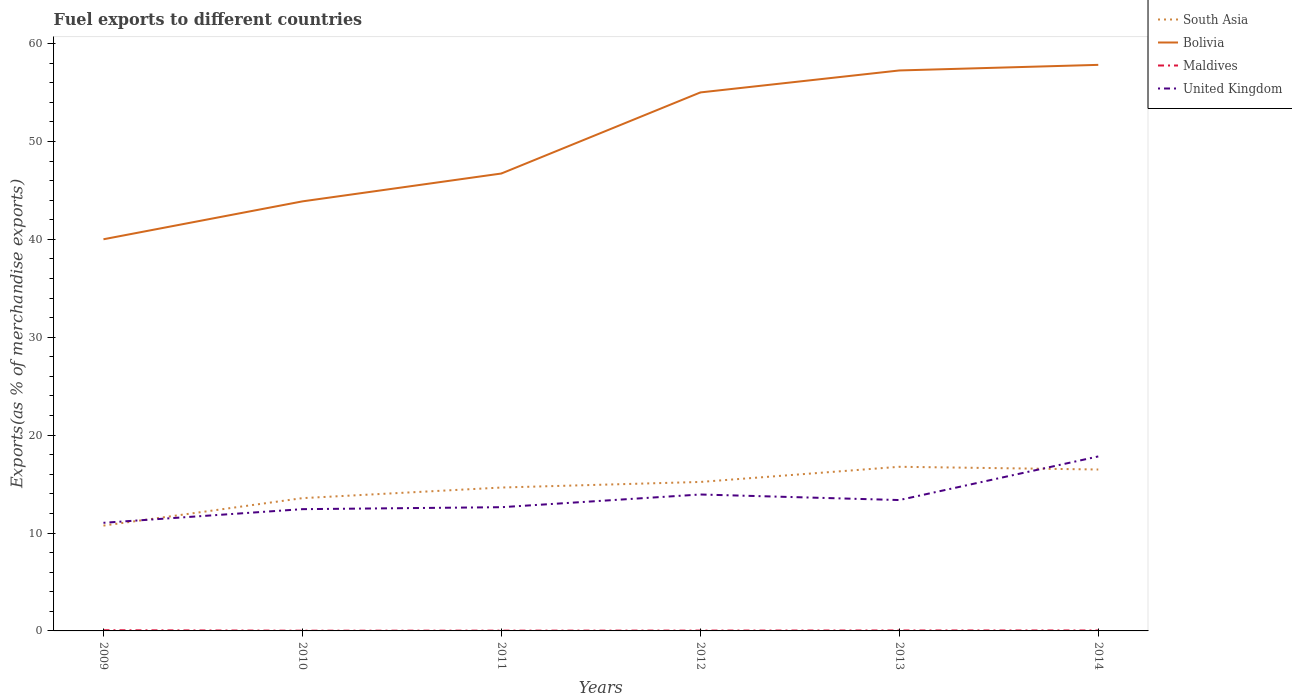How many different coloured lines are there?
Offer a very short reply. 4. Across all years, what is the maximum percentage of exports to different countries in South Asia?
Give a very brief answer. 10.76. In which year was the percentage of exports to different countries in South Asia maximum?
Provide a succinct answer. 2009. What is the total percentage of exports to different countries in United Kingdom in the graph?
Provide a succinct answer. -4.45. What is the difference between the highest and the second highest percentage of exports to different countries in Maldives?
Make the answer very short. 0.05. How many years are there in the graph?
Give a very brief answer. 6. Are the values on the major ticks of Y-axis written in scientific E-notation?
Make the answer very short. No. Does the graph contain any zero values?
Provide a short and direct response. No. Where does the legend appear in the graph?
Offer a terse response. Top right. How many legend labels are there?
Your response must be concise. 4. What is the title of the graph?
Give a very brief answer. Fuel exports to different countries. Does "Canada" appear as one of the legend labels in the graph?
Offer a terse response. No. What is the label or title of the Y-axis?
Make the answer very short. Exports(as % of merchandise exports). What is the Exports(as % of merchandise exports) in South Asia in 2009?
Provide a succinct answer. 10.76. What is the Exports(as % of merchandise exports) of Bolivia in 2009?
Ensure brevity in your answer.  40.01. What is the Exports(as % of merchandise exports) in Maldives in 2009?
Give a very brief answer. 0.07. What is the Exports(as % of merchandise exports) of United Kingdom in 2009?
Your response must be concise. 11.04. What is the Exports(as % of merchandise exports) in South Asia in 2010?
Ensure brevity in your answer.  13.56. What is the Exports(as % of merchandise exports) of Bolivia in 2010?
Your response must be concise. 43.88. What is the Exports(as % of merchandise exports) in Maldives in 2010?
Offer a terse response. 0.02. What is the Exports(as % of merchandise exports) in United Kingdom in 2010?
Give a very brief answer. 12.44. What is the Exports(as % of merchandise exports) of South Asia in 2011?
Your answer should be very brief. 14.65. What is the Exports(as % of merchandise exports) in Bolivia in 2011?
Provide a succinct answer. 46.72. What is the Exports(as % of merchandise exports) of Maldives in 2011?
Offer a terse response. 0.03. What is the Exports(as % of merchandise exports) in United Kingdom in 2011?
Keep it short and to the point. 12.64. What is the Exports(as % of merchandise exports) in South Asia in 2012?
Ensure brevity in your answer.  15.22. What is the Exports(as % of merchandise exports) of Bolivia in 2012?
Your response must be concise. 55.01. What is the Exports(as % of merchandise exports) of Maldives in 2012?
Keep it short and to the point. 0.03. What is the Exports(as % of merchandise exports) in United Kingdom in 2012?
Offer a terse response. 13.94. What is the Exports(as % of merchandise exports) of South Asia in 2013?
Give a very brief answer. 16.77. What is the Exports(as % of merchandise exports) in Bolivia in 2013?
Give a very brief answer. 57.25. What is the Exports(as % of merchandise exports) in Maldives in 2013?
Give a very brief answer. 0.05. What is the Exports(as % of merchandise exports) in United Kingdom in 2013?
Your answer should be compact. 13.37. What is the Exports(as % of merchandise exports) of South Asia in 2014?
Your response must be concise. 16.49. What is the Exports(as % of merchandise exports) in Bolivia in 2014?
Provide a short and direct response. 57.82. What is the Exports(as % of merchandise exports) in Maldives in 2014?
Make the answer very short. 0.05. What is the Exports(as % of merchandise exports) in United Kingdom in 2014?
Provide a short and direct response. 17.82. Across all years, what is the maximum Exports(as % of merchandise exports) in South Asia?
Provide a short and direct response. 16.77. Across all years, what is the maximum Exports(as % of merchandise exports) in Bolivia?
Provide a succinct answer. 57.82. Across all years, what is the maximum Exports(as % of merchandise exports) in Maldives?
Ensure brevity in your answer.  0.07. Across all years, what is the maximum Exports(as % of merchandise exports) of United Kingdom?
Make the answer very short. 17.82. Across all years, what is the minimum Exports(as % of merchandise exports) in South Asia?
Give a very brief answer. 10.76. Across all years, what is the minimum Exports(as % of merchandise exports) in Bolivia?
Your answer should be compact. 40.01. Across all years, what is the minimum Exports(as % of merchandise exports) of Maldives?
Give a very brief answer. 0.02. Across all years, what is the minimum Exports(as % of merchandise exports) of United Kingdom?
Offer a very short reply. 11.04. What is the total Exports(as % of merchandise exports) of South Asia in the graph?
Offer a very short reply. 87.44. What is the total Exports(as % of merchandise exports) of Bolivia in the graph?
Your answer should be very brief. 300.69. What is the total Exports(as % of merchandise exports) in Maldives in the graph?
Make the answer very short. 0.25. What is the total Exports(as % of merchandise exports) in United Kingdom in the graph?
Make the answer very short. 81.25. What is the difference between the Exports(as % of merchandise exports) of South Asia in 2009 and that in 2010?
Your answer should be compact. -2.8. What is the difference between the Exports(as % of merchandise exports) in Bolivia in 2009 and that in 2010?
Provide a short and direct response. -3.87. What is the difference between the Exports(as % of merchandise exports) in Maldives in 2009 and that in 2010?
Ensure brevity in your answer.  0.05. What is the difference between the Exports(as % of merchandise exports) in United Kingdom in 2009 and that in 2010?
Your answer should be very brief. -1.39. What is the difference between the Exports(as % of merchandise exports) in South Asia in 2009 and that in 2011?
Offer a terse response. -3.89. What is the difference between the Exports(as % of merchandise exports) in Bolivia in 2009 and that in 2011?
Make the answer very short. -6.72. What is the difference between the Exports(as % of merchandise exports) of Maldives in 2009 and that in 2011?
Your answer should be very brief. 0.04. What is the difference between the Exports(as % of merchandise exports) of United Kingdom in 2009 and that in 2011?
Your answer should be very brief. -1.59. What is the difference between the Exports(as % of merchandise exports) of South Asia in 2009 and that in 2012?
Make the answer very short. -4.46. What is the difference between the Exports(as % of merchandise exports) of Bolivia in 2009 and that in 2012?
Ensure brevity in your answer.  -15. What is the difference between the Exports(as % of merchandise exports) of Maldives in 2009 and that in 2012?
Ensure brevity in your answer.  0.04. What is the difference between the Exports(as % of merchandise exports) in United Kingdom in 2009 and that in 2012?
Make the answer very short. -2.89. What is the difference between the Exports(as % of merchandise exports) in South Asia in 2009 and that in 2013?
Provide a short and direct response. -6.01. What is the difference between the Exports(as % of merchandise exports) of Bolivia in 2009 and that in 2013?
Provide a succinct answer. -17.24. What is the difference between the Exports(as % of merchandise exports) of Maldives in 2009 and that in 2013?
Provide a succinct answer. 0.03. What is the difference between the Exports(as % of merchandise exports) in United Kingdom in 2009 and that in 2013?
Keep it short and to the point. -2.32. What is the difference between the Exports(as % of merchandise exports) in South Asia in 2009 and that in 2014?
Your answer should be compact. -5.73. What is the difference between the Exports(as % of merchandise exports) of Bolivia in 2009 and that in 2014?
Give a very brief answer. -17.81. What is the difference between the Exports(as % of merchandise exports) in Maldives in 2009 and that in 2014?
Ensure brevity in your answer.  0.03. What is the difference between the Exports(as % of merchandise exports) in United Kingdom in 2009 and that in 2014?
Give a very brief answer. -6.78. What is the difference between the Exports(as % of merchandise exports) of South Asia in 2010 and that in 2011?
Provide a succinct answer. -1.08. What is the difference between the Exports(as % of merchandise exports) in Bolivia in 2010 and that in 2011?
Your answer should be compact. -2.85. What is the difference between the Exports(as % of merchandise exports) of Maldives in 2010 and that in 2011?
Ensure brevity in your answer.  -0.01. What is the difference between the Exports(as % of merchandise exports) of United Kingdom in 2010 and that in 2011?
Ensure brevity in your answer.  -0.2. What is the difference between the Exports(as % of merchandise exports) of South Asia in 2010 and that in 2012?
Make the answer very short. -1.65. What is the difference between the Exports(as % of merchandise exports) in Bolivia in 2010 and that in 2012?
Make the answer very short. -11.13. What is the difference between the Exports(as % of merchandise exports) of Maldives in 2010 and that in 2012?
Your response must be concise. -0.01. What is the difference between the Exports(as % of merchandise exports) of United Kingdom in 2010 and that in 2012?
Offer a very short reply. -1.5. What is the difference between the Exports(as % of merchandise exports) of South Asia in 2010 and that in 2013?
Make the answer very short. -3.2. What is the difference between the Exports(as % of merchandise exports) of Bolivia in 2010 and that in 2013?
Your answer should be compact. -13.37. What is the difference between the Exports(as % of merchandise exports) in Maldives in 2010 and that in 2013?
Offer a terse response. -0.02. What is the difference between the Exports(as % of merchandise exports) in United Kingdom in 2010 and that in 2013?
Make the answer very short. -0.93. What is the difference between the Exports(as % of merchandise exports) of South Asia in 2010 and that in 2014?
Your answer should be very brief. -2.92. What is the difference between the Exports(as % of merchandise exports) in Bolivia in 2010 and that in 2014?
Provide a succinct answer. -13.94. What is the difference between the Exports(as % of merchandise exports) in Maldives in 2010 and that in 2014?
Give a very brief answer. -0.02. What is the difference between the Exports(as % of merchandise exports) in United Kingdom in 2010 and that in 2014?
Your answer should be very brief. -5.38. What is the difference between the Exports(as % of merchandise exports) of South Asia in 2011 and that in 2012?
Ensure brevity in your answer.  -0.57. What is the difference between the Exports(as % of merchandise exports) of Bolivia in 2011 and that in 2012?
Provide a succinct answer. -8.28. What is the difference between the Exports(as % of merchandise exports) in Maldives in 2011 and that in 2012?
Provide a succinct answer. -0.01. What is the difference between the Exports(as % of merchandise exports) of United Kingdom in 2011 and that in 2012?
Provide a short and direct response. -1.3. What is the difference between the Exports(as % of merchandise exports) of South Asia in 2011 and that in 2013?
Offer a terse response. -2.12. What is the difference between the Exports(as % of merchandise exports) in Bolivia in 2011 and that in 2013?
Keep it short and to the point. -10.53. What is the difference between the Exports(as % of merchandise exports) in Maldives in 2011 and that in 2013?
Make the answer very short. -0.02. What is the difference between the Exports(as % of merchandise exports) of United Kingdom in 2011 and that in 2013?
Provide a succinct answer. -0.73. What is the difference between the Exports(as % of merchandise exports) in South Asia in 2011 and that in 2014?
Make the answer very short. -1.84. What is the difference between the Exports(as % of merchandise exports) of Bolivia in 2011 and that in 2014?
Offer a terse response. -11.1. What is the difference between the Exports(as % of merchandise exports) in Maldives in 2011 and that in 2014?
Keep it short and to the point. -0.02. What is the difference between the Exports(as % of merchandise exports) in United Kingdom in 2011 and that in 2014?
Make the answer very short. -5.18. What is the difference between the Exports(as % of merchandise exports) in South Asia in 2012 and that in 2013?
Provide a succinct answer. -1.55. What is the difference between the Exports(as % of merchandise exports) of Bolivia in 2012 and that in 2013?
Your answer should be compact. -2.25. What is the difference between the Exports(as % of merchandise exports) in Maldives in 2012 and that in 2013?
Ensure brevity in your answer.  -0.01. What is the difference between the Exports(as % of merchandise exports) of United Kingdom in 2012 and that in 2013?
Offer a very short reply. 0.57. What is the difference between the Exports(as % of merchandise exports) in South Asia in 2012 and that in 2014?
Your answer should be compact. -1.27. What is the difference between the Exports(as % of merchandise exports) of Bolivia in 2012 and that in 2014?
Your answer should be compact. -2.82. What is the difference between the Exports(as % of merchandise exports) in Maldives in 2012 and that in 2014?
Your answer should be very brief. -0.01. What is the difference between the Exports(as % of merchandise exports) of United Kingdom in 2012 and that in 2014?
Ensure brevity in your answer.  -3.89. What is the difference between the Exports(as % of merchandise exports) in South Asia in 2013 and that in 2014?
Provide a short and direct response. 0.28. What is the difference between the Exports(as % of merchandise exports) of Bolivia in 2013 and that in 2014?
Your answer should be very brief. -0.57. What is the difference between the Exports(as % of merchandise exports) in Maldives in 2013 and that in 2014?
Provide a short and direct response. -0. What is the difference between the Exports(as % of merchandise exports) in United Kingdom in 2013 and that in 2014?
Provide a succinct answer. -4.45. What is the difference between the Exports(as % of merchandise exports) in South Asia in 2009 and the Exports(as % of merchandise exports) in Bolivia in 2010?
Offer a terse response. -33.12. What is the difference between the Exports(as % of merchandise exports) of South Asia in 2009 and the Exports(as % of merchandise exports) of Maldives in 2010?
Your answer should be very brief. 10.74. What is the difference between the Exports(as % of merchandise exports) of South Asia in 2009 and the Exports(as % of merchandise exports) of United Kingdom in 2010?
Your response must be concise. -1.68. What is the difference between the Exports(as % of merchandise exports) in Bolivia in 2009 and the Exports(as % of merchandise exports) in Maldives in 2010?
Provide a short and direct response. 39.98. What is the difference between the Exports(as % of merchandise exports) in Bolivia in 2009 and the Exports(as % of merchandise exports) in United Kingdom in 2010?
Keep it short and to the point. 27.57. What is the difference between the Exports(as % of merchandise exports) of Maldives in 2009 and the Exports(as % of merchandise exports) of United Kingdom in 2010?
Offer a terse response. -12.37. What is the difference between the Exports(as % of merchandise exports) of South Asia in 2009 and the Exports(as % of merchandise exports) of Bolivia in 2011?
Provide a short and direct response. -35.96. What is the difference between the Exports(as % of merchandise exports) of South Asia in 2009 and the Exports(as % of merchandise exports) of Maldives in 2011?
Keep it short and to the point. 10.73. What is the difference between the Exports(as % of merchandise exports) of South Asia in 2009 and the Exports(as % of merchandise exports) of United Kingdom in 2011?
Provide a succinct answer. -1.88. What is the difference between the Exports(as % of merchandise exports) in Bolivia in 2009 and the Exports(as % of merchandise exports) in Maldives in 2011?
Make the answer very short. 39.98. What is the difference between the Exports(as % of merchandise exports) of Bolivia in 2009 and the Exports(as % of merchandise exports) of United Kingdom in 2011?
Offer a terse response. 27.37. What is the difference between the Exports(as % of merchandise exports) of Maldives in 2009 and the Exports(as % of merchandise exports) of United Kingdom in 2011?
Keep it short and to the point. -12.57. What is the difference between the Exports(as % of merchandise exports) in South Asia in 2009 and the Exports(as % of merchandise exports) in Bolivia in 2012?
Provide a short and direct response. -44.25. What is the difference between the Exports(as % of merchandise exports) in South Asia in 2009 and the Exports(as % of merchandise exports) in Maldives in 2012?
Give a very brief answer. 10.73. What is the difference between the Exports(as % of merchandise exports) in South Asia in 2009 and the Exports(as % of merchandise exports) in United Kingdom in 2012?
Your answer should be compact. -3.18. What is the difference between the Exports(as % of merchandise exports) of Bolivia in 2009 and the Exports(as % of merchandise exports) of Maldives in 2012?
Provide a short and direct response. 39.97. What is the difference between the Exports(as % of merchandise exports) in Bolivia in 2009 and the Exports(as % of merchandise exports) in United Kingdom in 2012?
Your answer should be compact. 26.07. What is the difference between the Exports(as % of merchandise exports) in Maldives in 2009 and the Exports(as % of merchandise exports) in United Kingdom in 2012?
Give a very brief answer. -13.86. What is the difference between the Exports(as % of merchandise exports) in South Asia in 2009 and the Exports(as % of merchandise exports) in Bolivia in 2013?
Ensure brevity in your answer.  -46.49. What is the difference between the Exports(as % of merchandise exports) of South Asia in 2009 and the Exports(as % of merchandise exports) of Maldives in 2013?
Your answer should be very brief. 10.71. What is the difference between the Exports(as % of merchandise exports) of South Asia in 2009 and the Exports(as % of merchandise exports) of United Kingdom in 2013?
Ensure brevity in your answer.  -2.61. What is the difference between the Exports(as % of merchandise exports) of Bolivia in 2009 and the Exports(as % of merchandise exports) of Maldives in 2013?
Offer a very short reply. 39.96. What is the difference between the Exports(as % of merchandise exports) of Bolivia in 2009 and the Exports(as % of merchandise exports) of United Kingdom in 2013?
Your response must be concise. 26.64. What is the difference between the Exports(as % of merchandise exports) in Maldives in 2009 and the Exports(as % of merchandise exports) in United Kingdom in 2013?
Provide a short and direct response. -13.3. What is the difference between the Exports(as % of merchandise exports) in South Asia in 2009 and the Exports(as % of merchandise exports) in Bolivia in 2014?
Your answer should be very brief. -47.06. What is the difference between the Exports(as % of merchandise exports) of South Asia in 2009 and the Exports(as % of merchandise exports) of Maldives in 2014?
Ensure brevity in your answer.  10.71. What is the difference between the Exports(as % of merchandise exports) of South Asia in 2009 and the Exports(as % of merchandise exports) of United Kingdom in 2014?
Make the answer very short. -7.06. What is the difference between the Exports(as % of merchandise exports) in Bolivia in 2009 and the Exports(as % of merchandise exports) in Maldives in 2014?
Your answer should be very brief. 39.96. What is the difference between the Exports(as % of merchandise exports) in Bolivia in 2009 and the Exports(as % of merchandise exports) in United Kingdom in 2014?
Offer a very short reply. 22.18. What is the difference between the Exports(as % of merchandise exports) in Maldives in 2009 and the Exports(as % of merchandise exports) in United Kingdom in 2014?
Provide a short and direct response. -17.75. What is the difference between the Exports(as % of merchandise exports) of South Asia in 2010 and the Exports(as % of merchandise exports) of Bolivia in 2011?
Make the answer very short. -33.16. What is the difference between the Exports(as % of merchandise exports) in South Asia in 2010 and the Exports(as % of merchandise exports) in Maldives in 2011?
Your answer should be compact. 13.53. What is the difference between the Exports(as % of merchandise exports) in South Asia in 2010 and the Exports(as % of merchandise exports) in United Kingdom in 2011?
Give a very brief answer. 0.93. What is the difference between the Exports(as % of merchandise exports) of Bolivia in 2010 and the Exports(as % of merchandise exports) of Maldives in 2011?
Ensure brevity in your answer.  43.85. What is the difference between the Exports(as % of merchandise exports) in Bolivia in 2010 and the Exports(as % of merchandise exports) in United Kingdom in 2011?
Make the answer very short. 31.24. What is the difference between the Exports(as % of merchandise exports) in Maldives in 2010 and the Exports(as % of merchandise exports) in United Kingdom in 2011?
Provide a short and direct response. -12.62. What is the difference between the Exports(as % of merchandise exports) in South Asia in 2010 and the Exports(as % of merchandise exports) in Bolivia in 2012?
Provide a short and direct response. -41.44. What is the difference between the Exports(as % of merchandise exports) of South Asia in 2010 and the Exports(as % of merchandise exports) of Maldives in 2012?
Keep it short and to the point. 13.53. What is the difference between the Exports(as % of merchandise exports) of South Asia in 2010 and the Exports(as % of merchandise exports) of United Kingdom in 2012?
Your answer should be compact. -0.37. What is the difference between the Exports(as % of merchandise exports) in Bolivia in 2010 and the Exports(as % of merchandise exports) in Maldives in 2012?
Provide a short and direct response. 43.84. What is the difference between the Exports(as % of merchandise exports) of Bolivia in 2010 and the Exports(as % of merchandise exports) of United Kingdom in 2012?
Offer a very short reply. 29.94. What is the difference between the Exports(as % of merchandise exports) of Maldives in 2010 and the Exports(as % of merchandise exports) of United Kingdom in 2012?
Offer a terse response. -13.91. What is the difference between the Exports(as % of merchandise exports) of South Asia in 2010 and the Exports(as % of merchandise exports) of Bolivia in 2013?
Provide a succinct answer. -43.69. What is the difference between the Exports(as % of merchandise exports) in South Asia in 2010 and the Exports(as % of merchandise exports) in Maldives in 2013?
Offer a very short reply. 13.52. What is the difference between the Exports(as % of merchandise exports) of South Asia in 2010 and the Exports(as % of merchandise exports) of United Kingdom in 2013?
Your answer should be very brief. 0.19. What is the difference between the Exports(as % of merchandise exports) of Bolivia in 2010 and the Exports(as % of merchandise exports) of Maldives in 2013?
Ensure brevity in your answer.  43.83. What is the difference between the Exports(as % of merchandise exports) of Bolivia in 2010 and the Exports(as % of merchandise exports) of United Kingdom in 2013?
Make the answer very short. 30.51. What is the difference between the Exports(as % of merchandise exports) of Maldives in 2010 and the Exports(as % of merchandise exports) of United Kingdom in 2013?
Give a very brief answer. -13.35. What is the difference between the Exports(as % of merchandise exports) in South Asia in 2010 and the Exports(as % of merchandise exports) in Bolivia in 2014?
Your response must be concise. -44.26. What is the difference between the Exports(as % of merchandise exports) in South Asia in 2010 and the Exports(as % of merchandise exports) in Maldives in 2014?
Your response must be concise. 13.52. What is the difference between the Exports(as % of merchandise exports) of South Asia in 2010 and the Exports(as % of merchandise exports) of United Kingdom in 2014?
Make the answer very short. -4.26. What is the difference between the Exports(as % of merchandise exports) in Bolivia in 2010 and the Exports(as % of merchandise exports) in Maldives in 2014?
Your response must be concise. 43.83. What is the difference between the Exports(as % of merchandise exports) in Bolivia in 2010 and the Exports(as % of merchandise exports) in United Kingdom in 2014?
Keep it short and to the point. 26.06. What is the difference between the Exports(as % of merchandise exports) of Maldives in 2010 and the Exports(as % of merchandise exports) of United Kingdom in 2014?
Your response must be concise. -17.8. What is the difference between the Exports(as % of merchandise exports) in South Asia in 2011 and the Exports(as % of merchandise exports) in Bolivia in 2012?
Give a very brief answer. -40.36. What is the difference between the Exports(as % of merchandise exports) in South Asia in 2011 and the Exports(as % of merchandise exports) in Maldives in 2012?
Offer a terse response. 14.61. What is the difference between the Exports(as % of merchandise exports) in South Asia in 2011 and the Exports(as % of merchandise exports) in United Kingdom in 2012?
Make the answer very short. 0.71. What is the difference between the Exports(as % of merchandise exports) of Bolivia in 2011 and the Exports(as % of merchandise exports) of Maldives in 2012?
Keep it short and to the point. 46.69. What is the difference between the Exports(as % of merchandise exports) of Bolivia in 2011 and the Exports(as % of merchandise exports) of United Kingdom in 2012?
Ensure brevity in your answer.  32.79. What is the difference between the Exports(as % of merchandise exports) of Maldives in 2011 and the Exports(as % of merchandise exports) of United Kingdom in 2012?
Offer a very short reply. -13.91. What is the difference between the Exports(as % of merchandise exports) of South Asia in 2011 and the Exports(as % of merchandise exports) of Bolivia in 2013?
Offer a very short reply. -42.6. What is the difference between the Exports(as % of merchandise exports) of South Asia in 2011 and the Exports(as % of merchandise exports) of Maldives in 2013?
Make the answer very short. 14.6. What is the difference between the Exports(as % of merchandise exports) of South Asia in 2011 and the Exports(as % of merchandise exports) of United Kingdom in 2013?
Provide a succinct answer. 1.28. What is the difference between the Exports(as % of merchandise exports) in Bolivia in 2011 and the Exports(as % of merchandise exports) in Maldives in 2013?
Offer a very short reply. 46.68. What is the difference between the Exports(as % of merchandise exports) in Bolivia in 2011 and the Exports(as % of merchandise exports) in United Kingdom in 2013?
Your answer should be very brief. 33.36. What is the difference between the Exports(as % of merchandise exports) in Maldives in 2011 and the Exports(as % of merchandise exports) in United Kingdom in 2013?
Your answer should be very brief. -13.34. What is the difference between the Exports(as % of merchandise exports) of South Asia in 2011 and the Exports(as % of merchandise exports) of Bolivia in 2014?
Your answer should be compact. -43.17. What is the difference between the Exports(as % of merchandise exports) in South Asia in 2011 and the Exports(as % of merchandise exports) in Maldives in 2014?
Make the answer very short. 14.6. What is the difference between the Exports(as % of merchandise exports) of South Asia in 2011 and the Exports(as % of merchandise exports) of United Kingdom in 2014?
Your answer should be very brief. -3.17. What is the difference between the Exports(as % of merchandise exports) of Bolivia in 2011 and the Exports(as % of merchandise exports) of Maldives in 2014?
Give a very brief answer. 46.68. What is the difference between the Exports(as % of merchandise exports) in Bolivia in 2011 and the Exports(as % of merchandise exports) in United Kingdom in 2014?
Ensure brevity in your answer.  28.9. What is the difference between the Exports(as % of merchandise exports) in Maldives in 2011 and the Exports(as % of merchandise exports) in United Kingdom in 2014?
Make the answer very short. -17.79. What is the difference between the Exports(as % of merchandise exports) in South Asia in 2012 and the Exports(as % of merchandise exports) in Bolivia in 2013?
Your answer should be compact. -42.03. What is the difference between the Exports(as % of merchandise exports) of South Asia in 2012 and the Exports(as % of merchandise exports) of Maldives in 2013?
Ensure brevity in your answer.  15.17. What is the difference between the Exports(as % of merchandise exports) in South Asia in 2012 and the Exports(as % of merchandise exports) in United Kingdom in 2013?
Provide a short and direct response. 1.85. What is the difference between the Exports(as % of merchandise exports) in Bolivia in 2012 and the Exports(as % of merchandise exports) in Maldives in 2013?
Give a very brief answer. 54.96. What is the difference between the Exports(as % of merchandise exports) in Bolivia in 2012 and the Exports(as % of merchandise exports) in United Kingdom in 2013?
Provide a succinct answer. 41.64. What is the difference between the Exports(as % of merchandise exports) in Maldives in 2012 and the Exports(as % of merchandise exports) in United Kingdom in 2013?
Your answer should be compact. -13.33. What is the difference between the Exports(as % of merchandise exports) in South Asia in 2012 and the Exports(as % of merchandise exports) in Bolivia in 2014?
Keep it short and to the point. -42.6. What is the difference between the Exports(as % of merchandise exports) of South Asia in 2012 and the Exports(as % of merchandise exports) of Maldives in 2014?
Provide a short and direct response. 15.17. What is the difference between the Exports(as % of merchandise exports) in South Asia in 2012 and the Exports(as % of merchandise exports) in United Kingdom in 2014?
Your answer should be very brief. -2.6. What is the difference between the Exports(as % of merchandise exports) of Bolivia in 2012 and the Exports(as % of merchandise exports) of Maldives in 2014?
Offer a very short reply. 54.96. What is the difference between the Exports(as % of merchandise exports) in Bolivia in 2012 and the Exports(as % of merchandise exports) in United Kingdom in 2014?
Offer a very short reply. 37.18. What is the difference between the Exports(as % of merchandise exports) in Maldives in 2012 and the Exports(as % of merchandise exports) in United Kingdom in 2014?
Ensure brevity in your answer.  -17.79. What is the difference between the Exports(as % of merchandise exports) of South Asia in 2013 and the Exports(as % of merchandise exports) of Bolivia in 2014?
Offer a terse response. -41.05. What is the difference between the Exports(as % of merchandise exports) in South Asia in 2013 and the Exports(as % of merchandise exports) in Maldives in 2014?
Keep it short and to the point. 16.72. What is the difference between the Exports(as % of merchandise exports) in South Asia in 2013 and the Exports(as % of merchandise exports) in United Kingdom in 2014?
Your answer should be compact. -1.06. What is the difference between the Exports(as % of merchandise exports) in Bolivia in 2013 and the Exports(as % of merchandise exports) in Maldives in 2014?
Your answer should be very brief. 57.2. What is the difference between the Exports(as % of merchandise exports) in Bolivia in 2013 and the Exports(as % of merchandise exports) in United Kingdom in 2014?
Give a very brief answer. 39.43. What is the difference between the Exports(as % of merchandise exports) in Maldives in 2013 and the Exports(as % of merchandise exports) in United Kingdom in 2014?
Provide a short and direct response. -17.78. What is the average Exports(as % of merchandise exports) in South Asia per year?
Ensure brevity in your answer.  14.57. What is the average Exports(as % of merchandise exports) in Bolivia per year?
Make the answer very short. 50.11. What is the average Exports(as % of merchandise exports) in Maldives per year?
Ensure brevity in your answer.  0.04. What is the average Exports(as % of merchandise exports) in United Kingdom per year?
Offer a terse response. 13.54. In the year 2009, what is the difference between the Exports(as % of merchandise exports) of South Asia and Exports(as % of merchandise exports) of Bolivia?
Make the answer very short. -29.25. In the year 2009, what is the difference between the Exports(as % of merchandise exports) in South Asia and Exports(as % of merchandise exports) in Maldives?
Offer a very short reply. 10.69. In the year 2009, what is the difference between the Exports(as % of merchandise exports) in South Asia and Exports(as % of merchandise exports) in United Kingdom?
Ensure brevity in your answer.  -0.28. In the year 2009, what is the difference between the Exports(as % of merchandise exports) of Bolivia and Exports(as % of merchandise exports) of Maldives?
Keep it short and to the point. 39.93. In the year 2009, what is the difference between the Exports(as % of merchandise exports) in Bolivia and Exports(as % of merchandise exports) in United Kingdom?
Your answer should be compact. 28.96. In the year 2009, what is the difference between the Exports(as % of merchandise exports) of Maldives and Exports(as % of merchandise exports) of United Kingdom?
Give a very brief answer. -10.97. In the year 2010, what is the difference between the Exports(as % of merchandise exports) in South Asia and Exports(as % of merchandise exports) in Bolivia?
Offer a terse response. -30.31. In the year 2010, what is the difference between the Exports(as % of merchandise exports) of South Asia and Exports(as % of merchandise exports) of Maldives?
Ensure brevity in your answer.  13.54. In the year 2010, what is the difference between the Exports(as % of merchandise exports) of South Asia and Exports(as % of merchandise exports) of United Kingdom?
Your answer should be compact. 1.13. In the year 2010, what is the difference between the Exports(as % of merchandise exports) in Bolivia and Exports(as % of merchandise exports) in Maldives?
Provide a short and direct response. 43.85. In the year 2010, what is the difference between the Exports(as % of merchandise exports) of Bolivia and Exports(as % of merchandise exports) of United Kingdom?
Make the answer very short. 31.44. In the year 2010, what is the difference between the Exports(as % of merchandise exports) in Maldives and Exports(as % of merchandise exports) in United Kingdom?
Your response must be concise. -12.41. In the year 2011, what is the difference between the Exports(as % of merchandise exports) in South Asia and Exports(as % of merchandise exports) in Bolivia?
Provide a short and direct response. -32.08. In the year 2011, what is the difference between the Exports(as % of merchandise exports) of South Asia and Exports(as % of merchandise exports) of Maldives?
Offer a terse response. 14.62. In the year 2011, what is the difference between the Exports(as % of merchandise exports) of South Asia and Exports(as % of merchandise exports) of United Kingdom?
Give a very brief answer. 2.01. In the year 2011, what is the difference between the Exports(as % of merchandise exports) in Bolivia and Exports(as % of merchandise exports) in Maldives?
Give a very brief answer. 46.7. In the year 2011, what is the difference between the Exports(as % of merchandise exports) in Bolivia and Exports(as % of merchandise exports) in United Kingdom?
Offer a very short reply. 34.09. In the year 2011, what is the difference between the Exports(as % of merchandise exports) in Maldives and Exports(as % of merchandise exports) in United Kingdom?
Offer a terse response. -12.61. In the year 2012, what is the difference between the Exports(as % of merchandise exports) in South Asia and Exports(as % of merchandise exports) in Bolivia?
Your answer should be very brief. -39.79. In the year 2012, what is the difference between the Exports(as % of merchandise exports) of South Asia and Exports(as % of merchandise exports) of Maldives?
Offer a terse response. 15.18. In the year 2012, what is the difference between the Exports(as % of merchandise exports) of South Asia and Exports(as % of merchandise exports) of United Kingdom?
Offer a very short reply. 1.28. In the year 2012, what is the difference between the Exports(as % of merchandise exports) in Bolivia and Exports(as % of merchandise exports) in Maldives?
Give a very brief answer. 54.97. In the year 2012, what is the difference between the Exports(as % of merchandise exports) of Bolivia and Exports(as % of merchandise exports) of United Kingdom?
Your response must be concise. 41.07. In the year 2012, what is the difference between the Exports(as % of merchandise exports) of Maldives and Exports(as % of merchandise exports) of United Kingdom?
Offer a terse response. -13.9. In the year 2013, what is the difference between the Exports(as % of merchandise exports) of South Asia and Exports(as % of merchandise exports) of Bolivia?
Make the answer very short. -40.48. In the year 2013, what is the difference between the Exports(as % of merchandise exports) in South Asia and Exports(as % of merchandise exports) in Maldives?
Give a very brief answer. 16.72. In the year 2013, what is the difference between the Exports(as % of merchandise exports) in South Asia and Exports(as % of merchandise exports) in United Kingdom?
Give a very brief answer. 3.4. In the year 2013, what is the difference between the Exports(as % of merchandise exports) of Bolivia and Exports(as % of merchandise exports) of Maldives?
Your answer should be very brief. 57.2. In the year 2013, what is the difference between the Exports(as % of merchandise exports) of Bolivia and Exports(as % of merchandise exports) of United Kingdom?
Provide a short and direct response. 43.88. In the year 2013, what is the difference between the Exports(as % of merchandise exports) in Maldives and Exports(as % of merchandise exports) in United Kingdom?
Your response must be concise. -13.32. In the year 2014, what is the difference between the Exports(as % of merchandise exports) of South Asia and Exports(as % of merchandise exports) of Bolivia?
Offer a very short reply. -41.33. In the year 2014, what is the difference between the Exports(as % of merchandise exports) of South Asia and Exports(as % of merchandise exports) of Maldives?
Offer a very short reply. 16.44. In the year 2014, what is the difference between the Exports(as % of merchandise exports) in South Asia and Exports(as % of merchandise exports) in United Kingdom?
Make the answer very short. -1.33. In the year 2014, what is the difference between the Exports(as % of merchandise exports) in Bolivia and Exports(as % of merchandise exports) in Maldives?
Provide a short and direct response. 57.77. In the year 2014, what is the difference between the Exports(as % of merchandise exports) in Bolivia and Exports(as % of merchandise exports) in United Kingdom?
Provide a short and direct response. 40. In the year 2014, what is the difference between the Exports(as % of merchandise exports) in Maldives and Exports(as % of merchandise exports) in United Kingdom?
Your response must be concise. -17.78. What is the ratio of the Exports(as % of merchandise exports) of South Asia in 2009 to that in 2010?
Ensure brevity in your answer.  0.79. What is the ratio of the Exports(as % of merchandise exports) in Bolivia in 2009 to that in 2010?
Provide a succinct answer. 0.91. What is the ratio of the Exports(as % of merchandise exports) of Maldives in 2009 to that in 2010?
Your response must be concise. 3.12. What is the ratio of the Exports(as % of merchandise exports) of United Kingdom in 2009 to that in 2010?
Keep it short and to the point. 0.89. What is the ratio of the Exports(as % of merchandise exports) of South Asia in 2009 to that in 2011?
Make the answer very short. 0.73. What is the ratio of the Exports(as % of merchandise exports) of Bolivia in 2009 to that in 2011?
Make the answer very short. 0.86. What is the ratio of the Exports(as % of merchandise exports) of Maldives in 2009 to that in 2011?
Your answer should be very brief. 2.48. What is the ratio of the Exports(as % of merchandise exports) in United Kingdom in 2009 to that in 2011?
Ensure brevity in your answer.  0.87. What is the ratio of the Exports(as % of merchandise exports) in South Asia in 2009 to that in 2012?
Make the answer very short. 0.71. What is the ratio of the Exports(as % of merchandise exports) of Bolivia in 2009 to that in 2012?
Your response must be concise. 0.73. What is the ratio of the Exports(as % of merchandise exports) of Maldives in 2009 to that in 2012?
Give a very brief answer. 2.11. What is the ratio of the Exports(as % of merchandise exports) of United Kingdom in 2009 to that in 2012?
Offer a terse response. 0.79. What is the ratio of the Exports(as % of merchandise exports) of South Asia in 2009 to that in 2013?
Provide a short and direct response. 0.64. What is the ratio of the Exports(as % of merchandise exports) of Bolivia in 2009 to that in 2013?
Offer a terse response. 0.7. What is the ratio of the Exports(as % of merchandise exports) in Maldives in 2009 to that in 2013?
Offer a very short reply. 1.56. What is the ratio of the Exports(as % of merchandise exports) of United Kingdom in 2009 to that in 2013?
Offer a very short reply. 0.83. What is the ratio of the Exports(as % of merchandise exports) in South Asia in 2009 to that in 2014?
Keep it short and to the point. 0.65. What is the ratio of the Exports(as % of merchandise exports) in Bolivia in 2009 to that in 2014?
Offer a terse response. 0.69. What is the ratio of the Exports(as % of merchandise exports) of Maldives in 2009 to that in 2014?
Your answer should be compact. 1.55. What is the ratio of the Exports(as % of merchandise exports) of United Kingdom in 2009 to that in 2014?
Keep it short and to the point. 0.62. What is the ratio of the Exports(as % of merchandise exports) of South Asia in 2010 to that in 2011?
Your answer should be very brief. 0.93. What is the ratio of the Exports(as % of merchandise exports) of Bolivia in 2010 to that in 2011?
Provide a short and direct response. 0.94. What is the ratio of the Exports(as % of merchandise exports) of Maldives in 2010 to that in 2011?
Provide a succinct answer. 0.8. What is the ratio of the Exports(as % of merchandise exports) in United Kingdom in 2010 to that in 2011?
Keep it short and to the point. 0.98. What is the ratio of the Exports(as % of merchandise exports) of South Asia in 2010 to that in 2012?
Keep it short and to the point. 0.89. What is the ratio of the Exports(as % of merchandise exports) of Bolivia in 2010 to that in 2012?
Your answer should be compact. 0.8. What is the ratio of the Exports(as % of merchandise exports) in Maldives in 2010 to that in 2012?
Ensure brevity in your answer.  0.68. What is the ratio of the Exports(as % of merchandise exports) in United Kingdom in 2010 to that in 2012?
Provide a short and direct response. 0.89. What is the ratio of the Exports(as % of merchandise exports) in South Asia in 2010 to that in 2013?
Your response must be concise. 0.81. What is the ratio of the Exports(as % of merchandise exports) of Bolivia in 2010 to that in 2013?
Ensure brevity in your answer.  0.77. What is the ratio of the Exports(as % of merchandise exports) in Maldives in 2010 to that in 2013?
Provide a short and direct response. 0.5. What is the ratio of the Exports(as % of merchandise exports) in United Kingdom in 2010 to that in 2013?
Give a very brief answer. 0.93. What is the ratio of the Exports(as % of merchandise exports) of South Asia in 2010 to that in 2014?
Offer a terse response. 0.82. What is the ratio of the Exports(as % of merchandise exports) of Bolivia in 2010 to that in 2014?
Ensure brevity in your answer.  0.76. What is the ratio of the Exports(as % of merchandise exports) of Maldives in 2010 to that in 2014?
Offer a terse response. 0.5. What is the ratio of the Exports(as % of merchandise exports) in United Kingdom in 2010 to that in 2014?
Give a very brief answer. 0.7. What is the ratio of the Exports(as % of merchandise exports) of South Asia in 2011 to that in 2012?
Make the answer very short. 0.96. What is the ratio of the Exports(as % of merchandise exports) in Bolivia in 2011 to that in 2012?
Your response must be concise. 0.85. What is the ratio of the Exports(as % of merchandise exports) of Maldives in 2011 to that in 2012?
Provide a succinct answer. 0.85. What is the ratio of the Exports(as % of merchandise exports) in United Kingdom in 2011 to that in 2012?
Offer a very short reply. 0.91. What is the ratio of the Exports(as % of merchandise exports) of South Asia in 2011 to that in 2013?
Your answer should be compact. 0.87. What is the ratio of the Exports(as % of merchandise exports) in Bolivia in 2011 to that in 2013?
Ensure brevity in your answer.  0.82. What is the ratio of the Exports(as % of merchandise exports) in Maldives in 2011 to that in 2013?
Ensure brevity in your answer.  0.63. What is the ratio of the Exports(as % of merchandise exports) in United Kingdom in 2011 to that in 2013?
Your answer should be very brief. 0.95. What is the ratio of the Exports(as % of merchandise exports) of South Asia in 2011 to that in 2014?
Your answer should be very brief. 0.89. What is the ratio of the Exports(as % of merchandise exports) of Bolivia in 2011 to that in 2014?
Your answer should be compact. 0.81. What is the ratio of the Exports(as % of merchandise exports) in Maldives in 2011 to that in 2014?
Give a very brief answer. 0.62. What is the ratio of the Exports(as % of merchandise exports) of United Kingdom in 2011 to that in 2014?
Provide a succinct answer. 0.71. What is the ratio of the Exports(as % of merchandise exports) in South Asia in 2012 to that in 2013?
Your answer should be very brief. 0.91. What is the ratio of the Exports(as % of merchandise exports) in Bolivia in 2012 to that in 2013?
Your answer should be very brief. 0.96. What is the ratio of the Exports(as % of merchandise exports) in Maldives in 2012 to that in 2013?
Your answer should be compact. 0.74. What is the ratio of the Exports(as % of merchandise exports) of United Kingdom in 2012 to that in 2013?
Make the answer very short. 1.04. What is the ratio of the Exports(as % of merchandise exports) of South Asia in 2012 to that in 2014?
Ensure brevity in your answer.  0.92. What is the ratio of the Exports(as % of merchandise exports) of Bolivia in 2012 to that in 2014?
Keep it short and to the point. 0.95. What is the ratio of the Exports(as % of merchandise exports) of Maldives in 2012 to that in 2014?
Offer a very short reply. 0.73. What is the ratio of the Exports(as % of merchandise exports) in United Kingdom in 2012 to that in 2014?
Provide a succinct answer. 0.78. What is the ratio of the Exports(as % of merchandise exports) of South Asia in 2013 to that in 2014?
Offer a terse response. 1.02. What is the ratio of the Exports(as % of merchandise exports) of Bolivia in 2013 to that in 2014?
Keep it short and to the point. 0.99. What is the ratio of the Exports(as % of merchandise exports) in Maldives in 2013 to that in 2014?
Ensure brevity in your answer.  0.99. What is the ratio of the Exports(as % of merchandise exports) in United Kingdom in 2013 to that in 2014?
Offer a terse response. 0.75. What is the difference between the highest and the second highest Exports(as % of merchandise exports) in South Asia?
Make the answer very short. 0.28. What is the difference between the highest and the second highest Exports(as % of merchandise exports) of Bolivia?
Ensure brevity in your answer.  0.57. What is the difference between the highest and the second highest Exports(as % of merchandise exports) in Maldives?
Ensure brevity in your answer.  0.03. What is the difference between the highest and the second highest Exports(as % of merchandise exports) in United Kingdom?
Provide a succinct answer. 3.89. What is the difference between the highest and the lowest Exports(as % of merchandise exports) in South Asia?
Keep it short and to the point. 6.01. What is the difference between the highest and the lowest Exports(as % of merchandise exports) of Bolivia?
Provide a succinct answer. 17.81. What is the difference between the highest and the lowest Exports(as % of merchandise exports) in Maldives?
Ensure brevity in your answer.  0.05. What is the difference between the highest and the lowest Exports(as % of merchandise exports) in United Kingdom?
Ensure brevity in your answer.  6.78. 